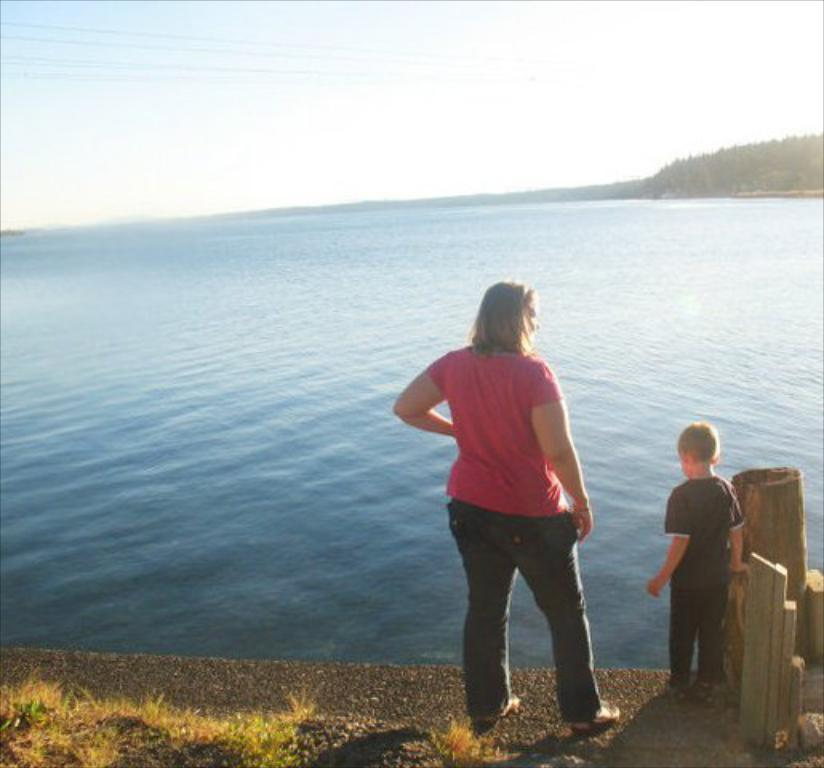How many people are present in the image? There are two people standing on the road in the image. What is in front of the people? There is a river in front of the people. What can be seen in the background of the image? There are trees and the sky visible in the background of the image. What color is the crayon being used by the person on the left? There is no crayon present in the image; it features two people standing on the road with a river in front of them and trees and the sky in the background. 